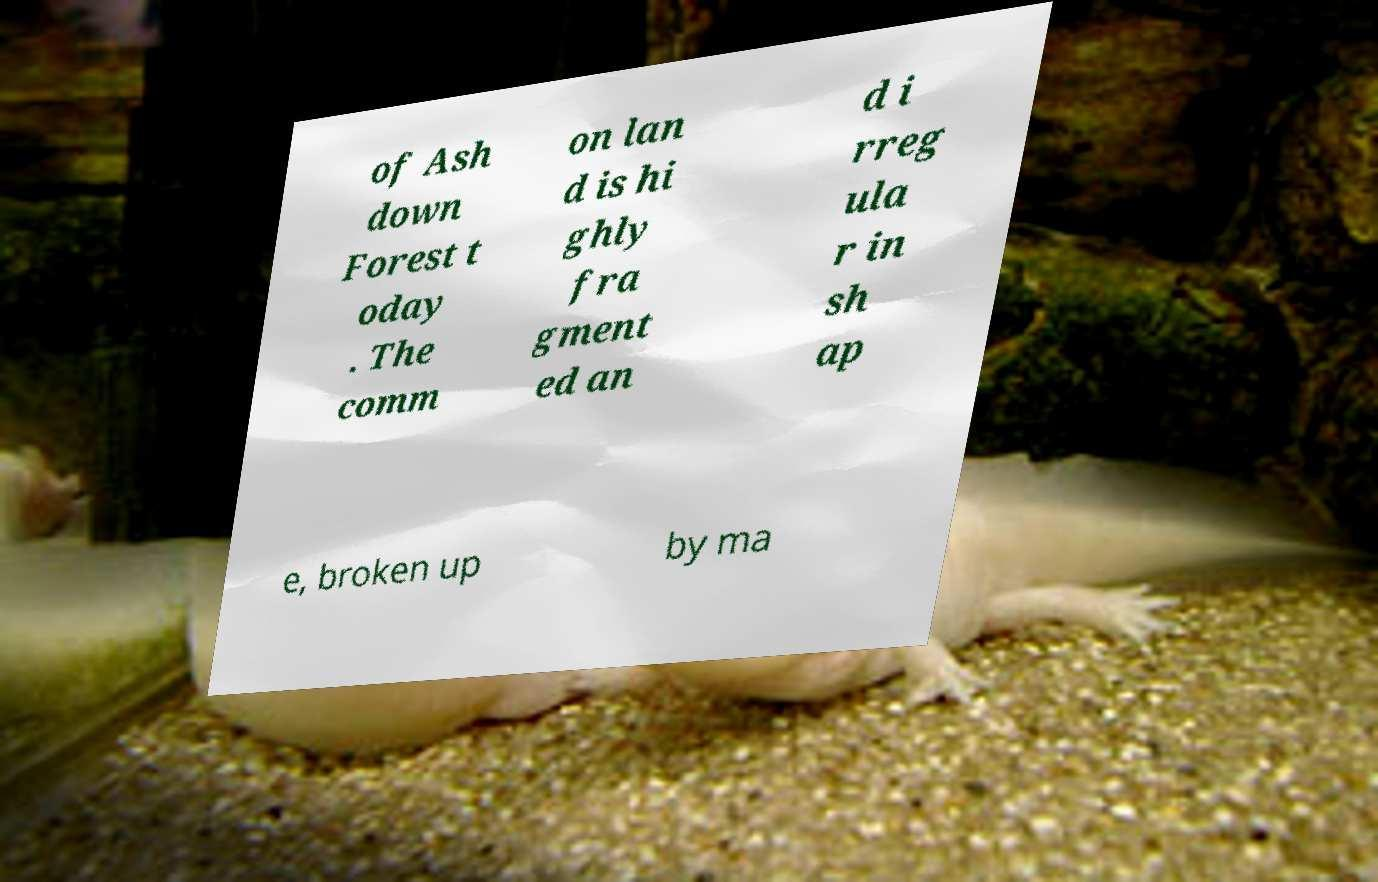I need the written content from this picture converted into text. Can you do that? of Ash down Forest t oday . The comm on lan d is hi ghly fra gment ed an d i rreg ula r in sh ap e, broken up by ma 